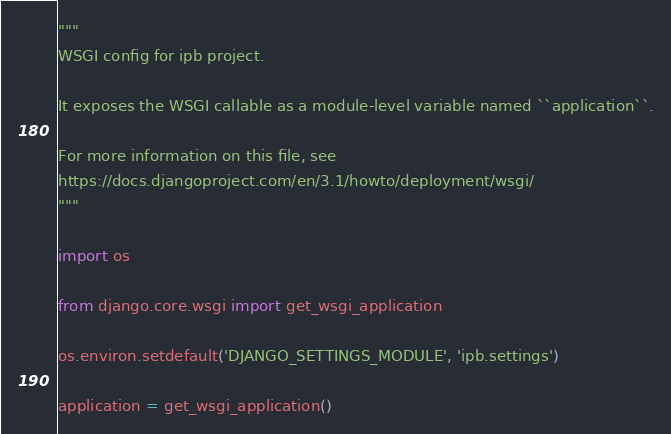<code> <loc_0><loc_0><loc_500><loc_500><_Python_>"""
WSGI config for ipb project.

It exposes the WSGI callable as a module-level variable named ``application``.

For more information on this file, see
https://docs.djangoproject.com/en/3.1/howto/deployment/wsgi/
"""

import os

from django.core.wsgi import get_wsgi_application

os.environ.setdefault('DJANGO_SETTINGS_MODULE', 'ipb.settings')

application = get_wsgi_application()
</code> 